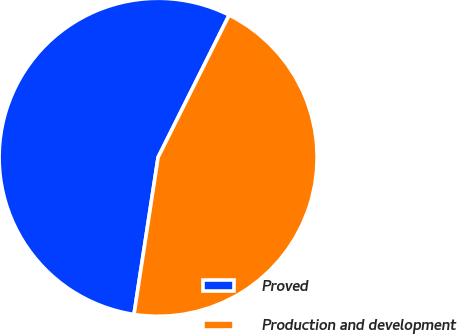Convert chart. <chart><loc_0><loc_0><loc_500><loc_500><pie_chart><fcel>Proved<fcel>Production and development<nl><fcel>54.95%<fcel>45.05%<nl></chart> 